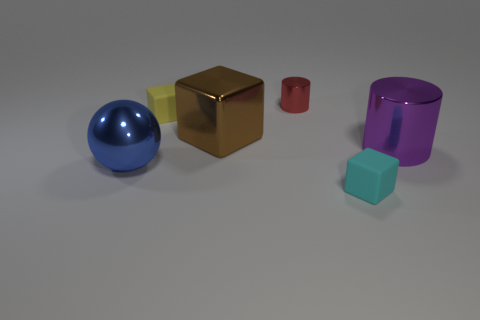What number of things are on the left side of the large purple shiny object behind the small object that is in front of the large blue sphere?
Offer a terse response. 5. The other matte object that is the same shape as the yellow matte object is what size?
Offer a very short reply. Small. Are the cube that is right of the red metallic cylinder and the small yellow thing made of the same material?
Ensure brevity in your answer.  Yes. The large object that is the same shape as the tiny red shiny object is what color?
Make the answer very short. Purple. There is a thing that is right of the cyan object; is its shape the same as the metal object that is behind the brown shiny thing?
Ensure brevity in your answer.  Yes. How many balls are either tiny cyan rubber things or small rubber objects?
Give a very brief answer. 0. Is the number of large brown shiny things that are left of the brown metal object less than the number of yellow things?
Give a very brief answer. Yes. How many other things are there of the same material as the cyan object?
Your answer should be very brief. 1. Is the yellow rubber block the same size as the cyan rubber object?
Offer a terse response. Yes. What number of objects are either small objects in front of the large metal cylinder or red matte things?
Make the answer very short. 1. 